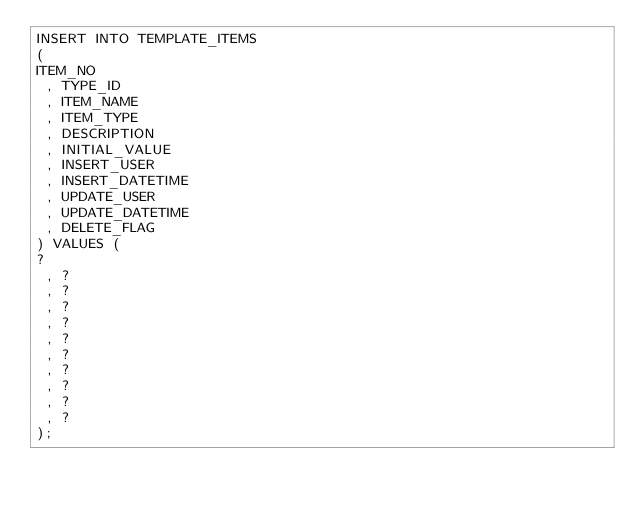<code> <loc_0><loc_0><loc_500><loc_500><_SQL_>INSERT INTO TEMPLATE_ITEMS
( 
ITEM_NO
 , TYPE_ID
 , ITEM_NAME
 , ITEM_TYPE
 , DESCRIPTION
 , INITIAL_VALUE
 , INSERT_USER
 , INSERT_DATETIME
 , UPDATE_USER
 , UPDATE_DATETIME
 , DELETE_FLAG
) VALUES (
?
 , ?
 , ?
 , ?
 , ?
 , ?
 , ?
 , ?
 , ?
 , ?
 , ?
);
</code> 